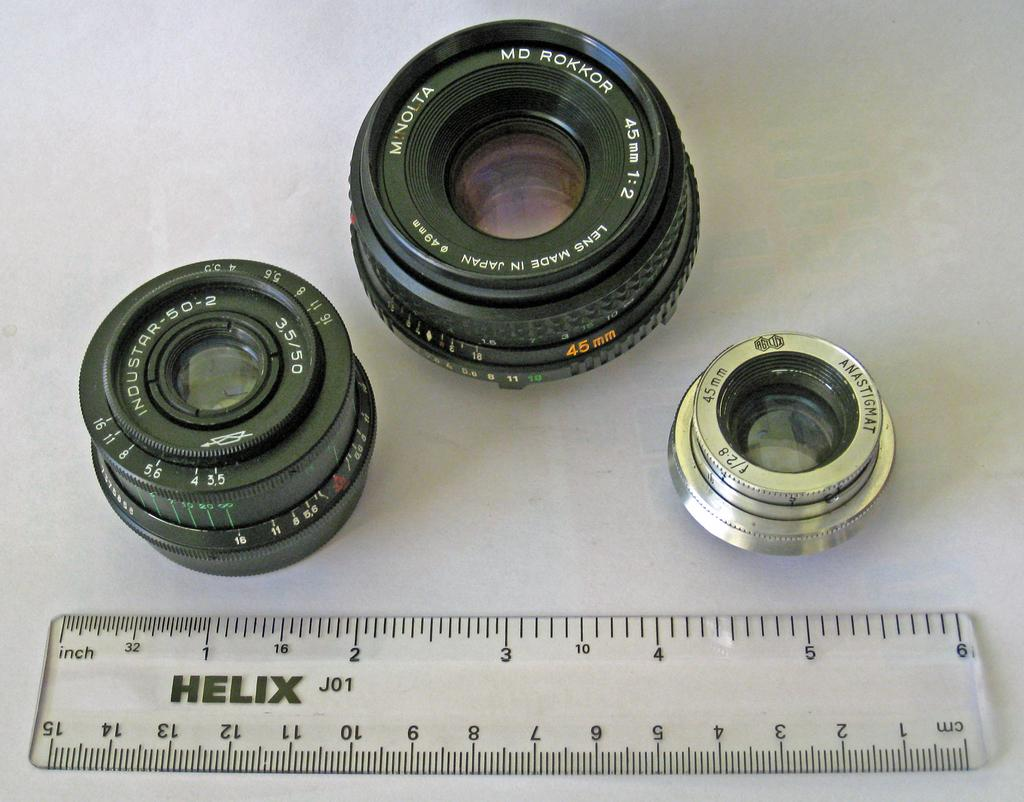<image>
Render a clear and concise summary of the photo. Black and silver camera lenses with MD ROKKOR in white letters. 